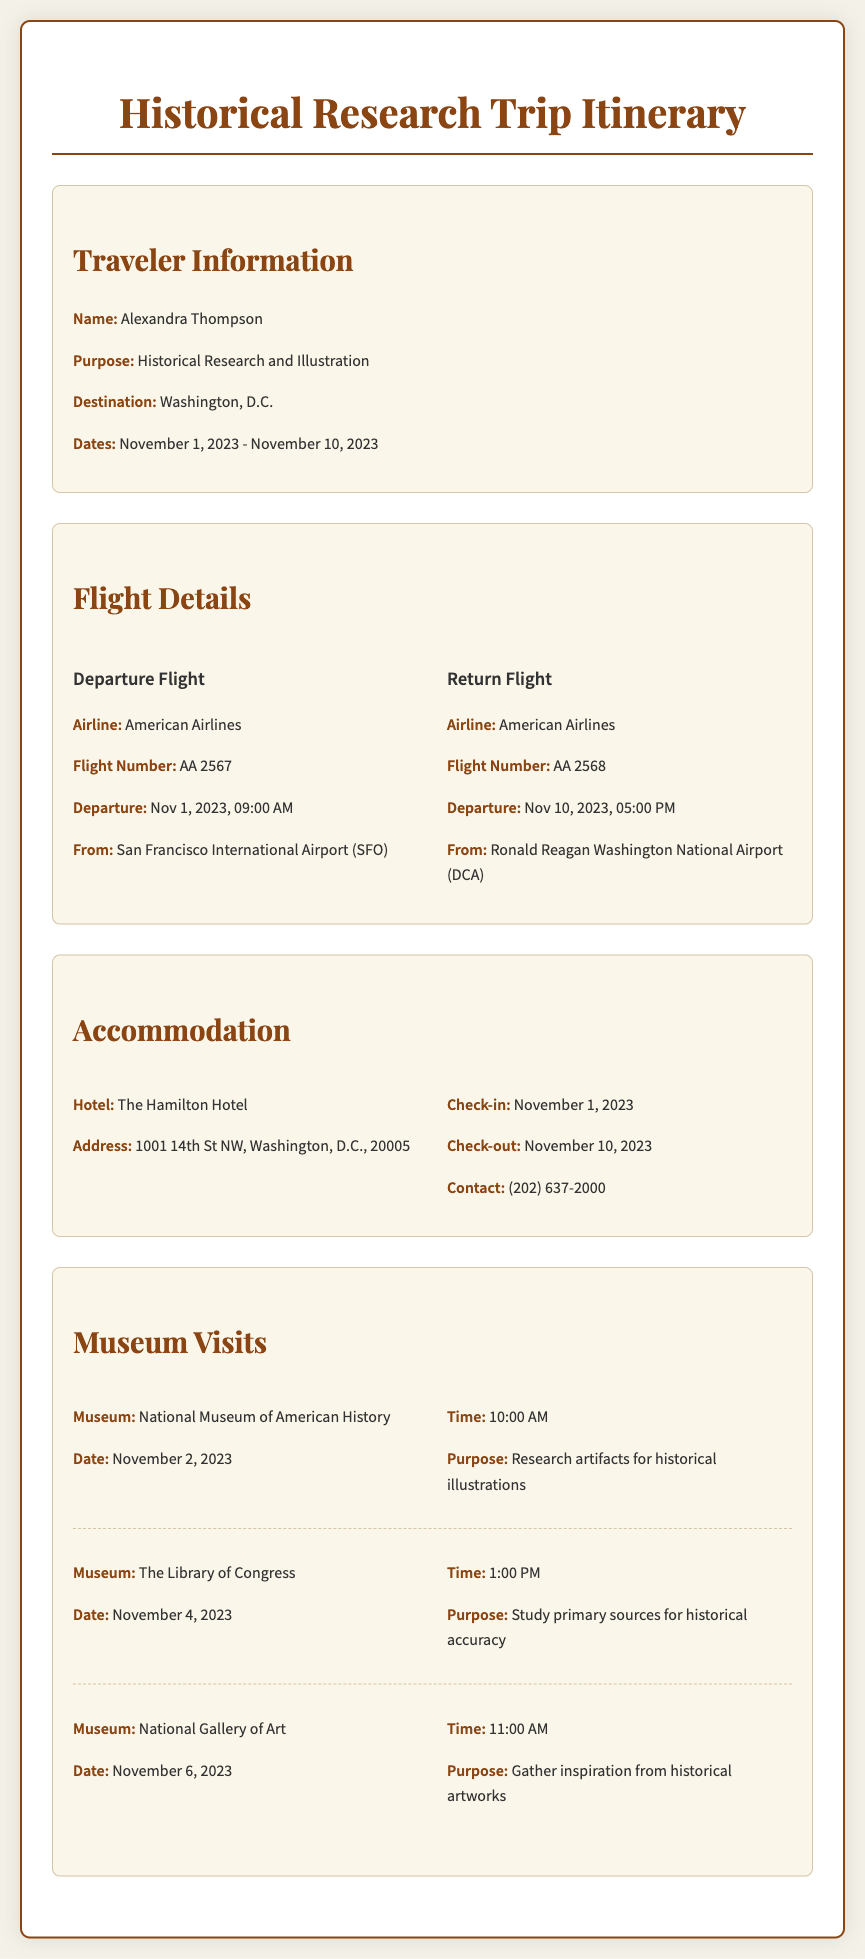what is the traveler's name? The traveler's name is mentioned in the "Traveler Information" section of the document.
Answer: Alexandra Thompson what is the destination of the trip? The destination is specified under "Traveler Information."
Answer: Washington, D.C when is the return flight scheduled? The return flight's schedule is provided in the "Flight Details" section.
Answer: Nov 10, 2023, 05:00 PM what hotel will the traveler stay at? The hotel name is listed in the "Accommodation" section of the itinerary.
Answer: The Hamilton Hotel how many museum visits are scheduled? The number of museum visits can be counted in the "Museum Visits" section of the document.
Answer: 3 what is the purpose of visiting the National Gallery of Art? The purpose is mentioned alongside the museum name and date in the "Museum Visits" section.
Answer: Gather inspiration from historical artworks what date is the visit to The Library of Congress? The visit date is specified next to the museum's name in the "Museum Visits" section.
Answer: November 4, 2023 which airline is used for the departure flight? The airline name is provided in the "Flight Details" section.
Answer: American Airlines what is the check-in date for the hotel? The check-in date is explicitly stated in the "Accommodation" section.
Answer: November 1, 2023 